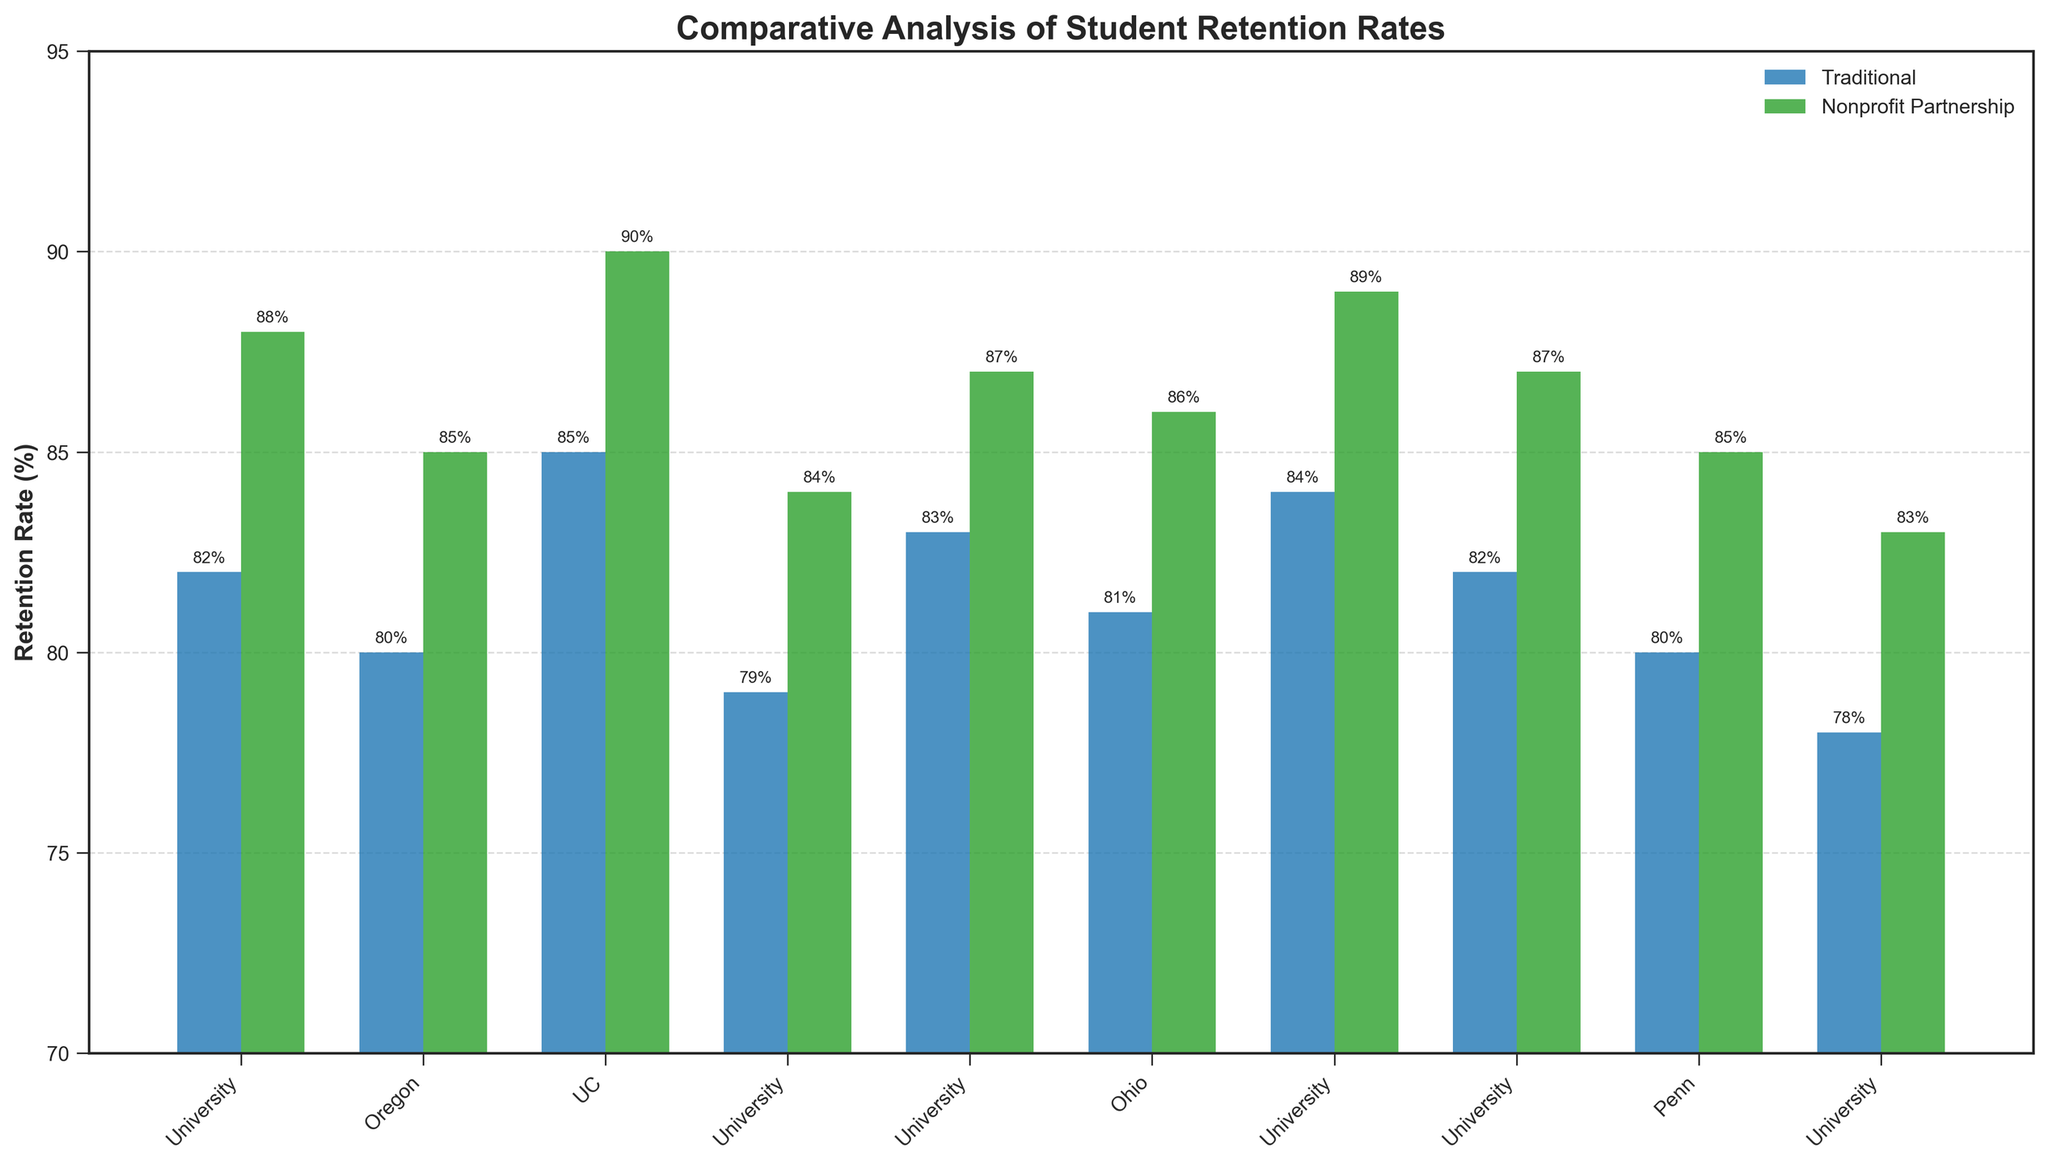Which program type has the highest retention rate overall? The highest retention rate is seen by looking for the tallest bar in either the Traditional or Nonprofit Partnership categories. The tallest bar belongs to UCSF-Nonprofit Partnership BSN with a retention rate of 90%.
Answer: UCSF-Nonprofit Partnership BSN What is the difference in retention rate between the University of Minnesota Traditional BSN and UMN-Nonprofit Partnership BSN programs? Subtract the retention rate of the traditional UMN program (79%) from that of the UMN Nonprofit Partnership program (84%). 84% - 79% = 5%
Answer: 5% Which university shows the greatest improvement in retention rate when comparing its traditional and nonprofit partnership programs? Compare the improvements by looking at the differences in retention rates for each university. The University of Illinois Chicago shows the greatest improvement of 5% (83% - 78%).
Answer: University of Illinois Chicago What's the average retention rate of nonprofit partnership programs across all universities? Sum up the retention rates of all the nonprofit partnership programs (88 + 85 + 90 + 84 + 87 + 86 + 89 + 87 + 85 + 83) and divide by the number of programs (10): (88 + 85 + 90 + 84 + 87 + 86 + 89 + 87 + 85 + 83)/10 = 87.4%
Answer: 87.4% Does any nonprofit partnership program have a lower retention rate than the highest retention rate of a traditional program? The highest retention rate of a traditional program is 85% (UC San Francisco Traditional BSN), and the lowest retention rate of a nonprofit partnership program is 83% (University of Illinois Chicago Nonprofit Partnership BSN). Since 83% < 85%, yes, there is one.
Answer: Yes Which university's nonprofit partnership program has the smallest increase in retention rate compared to its traditional program? Look at the differences in retention rates between traditional and nonprofit partnership programs for each university. The smallest increase is seen in the University of Washington with a 6% increase (88% - 82%).
Answer: University of Washington Between Ohio State University and Penn State University, which has a greater difference in retention rates between their traditional and nonprofit partnership programs? Calculate the differences: OSU has 86% - 81% = 5%, and PSU has 85% - 80% = 5%. Their differences are equal.
Answer: Equal How many universities have a retention rate of 85% or higher in their traditional programs? Count the universities with traditional programs that have retention rates of 85% or higher (UC San Francisco, University of Michigan, and University of North Carolina). There are three such universities.
Answer: 3 Which bar color represents the nonprofit partnership programs? Identify the color used for the nonprofit partnership bars in the chart. The nonprofit partnership programs are represented by green bars.
Answer: Green Does the University of Texas at Austin show a higher retention rate for its traditional or nonprofit partnership program? Compare the heights of the bars for the University of Texas at Austin. The Nonprofit Partnership program (87%) has a higher retention rate than the Traditional program (82%).
Answer: Nonprofit Partnership program 